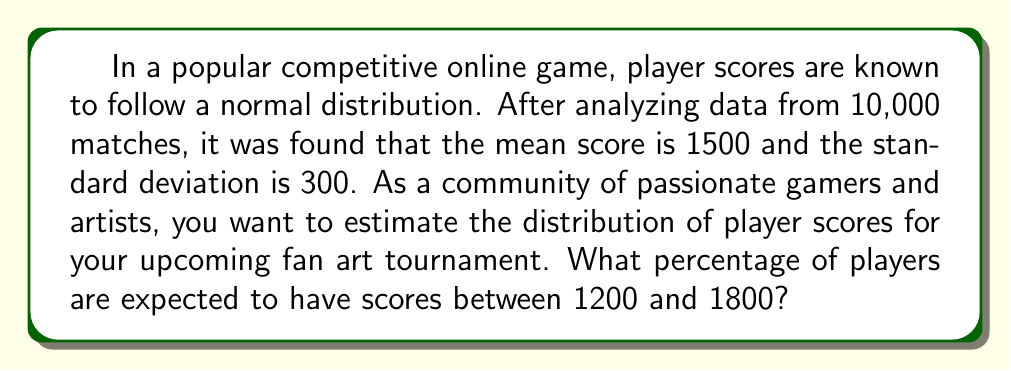Help me with this question. To solve this problem, we'll use the properties of the normal distribution and the concept of z-scores.

Step 1: Identify the given information
- Mean (μ) = 1500
- Standard deviation (σ) = 300
- We want to find the percentage of players between 1200 and 1800

Step 2: Calculate the z-scores for the lower and upper bounds
For the lower bound (1200):
$$ z_1 = \frac{1200 - 1500}{300} = -1 $$

For the upper bound (1800):
$$ z_2 = \frac{1800 - 1500}{300} = 1 $$

Step 3: Use the standard normal distribution table or a calculator to find the area between these z-scores
The area between z = -1 and z = 1 in a standard normal distribution is approximately 0.6826 or 68.26%.

Step 4: Interpret the result
This means that approximately 68.26% of players are expected to have scores between 1200 and 1800.

Note: This result is also known as the "68-95-99.7 rule" or the "empirical rule" for normal distributions, where approximately 68% of the data falls within one standard deviation of the mean.
Answer: 68.26% 